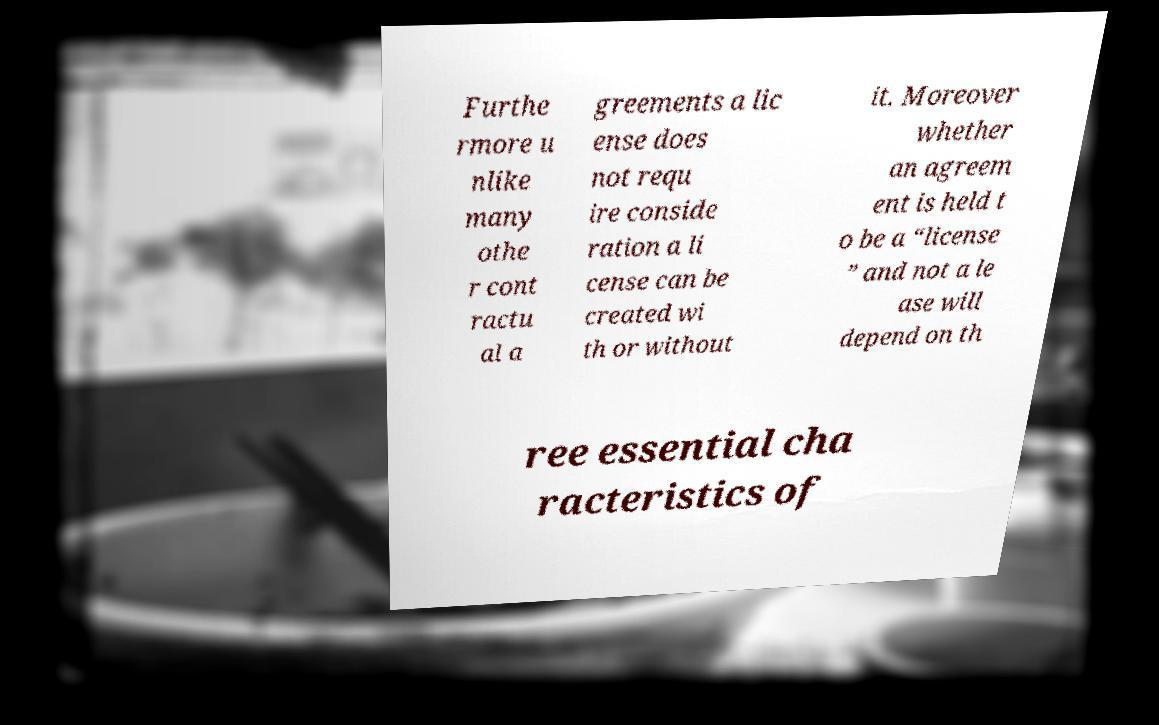Could you assist in decoding the text presented in this image and type it out clearly? Furthe rmore u nlike many othe r cont ractu al a greements a lic ense does not requ ire conside ration a li cense can be created wi th or without it. Moreover whether an agreem ent is held t o be a “license ” and not a le ase will depend on th ree essential cha racteristics of 